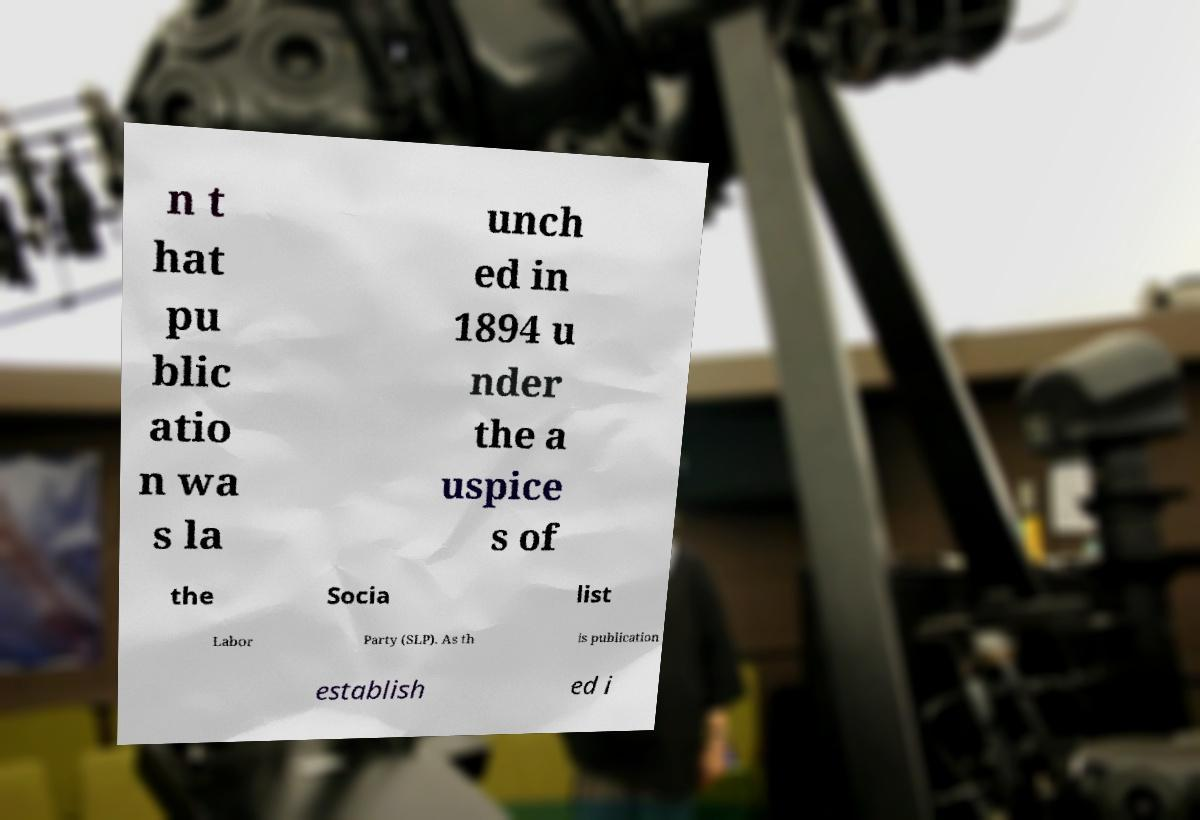There's text embedded in this image that I need extracted. Can you transcribe it verbatim? n t hat pu blic atio n wa s la unch ed in 1894 u nder the a uspice s of the Socia list Labor Party (SLP). As th is publication establish ed i 